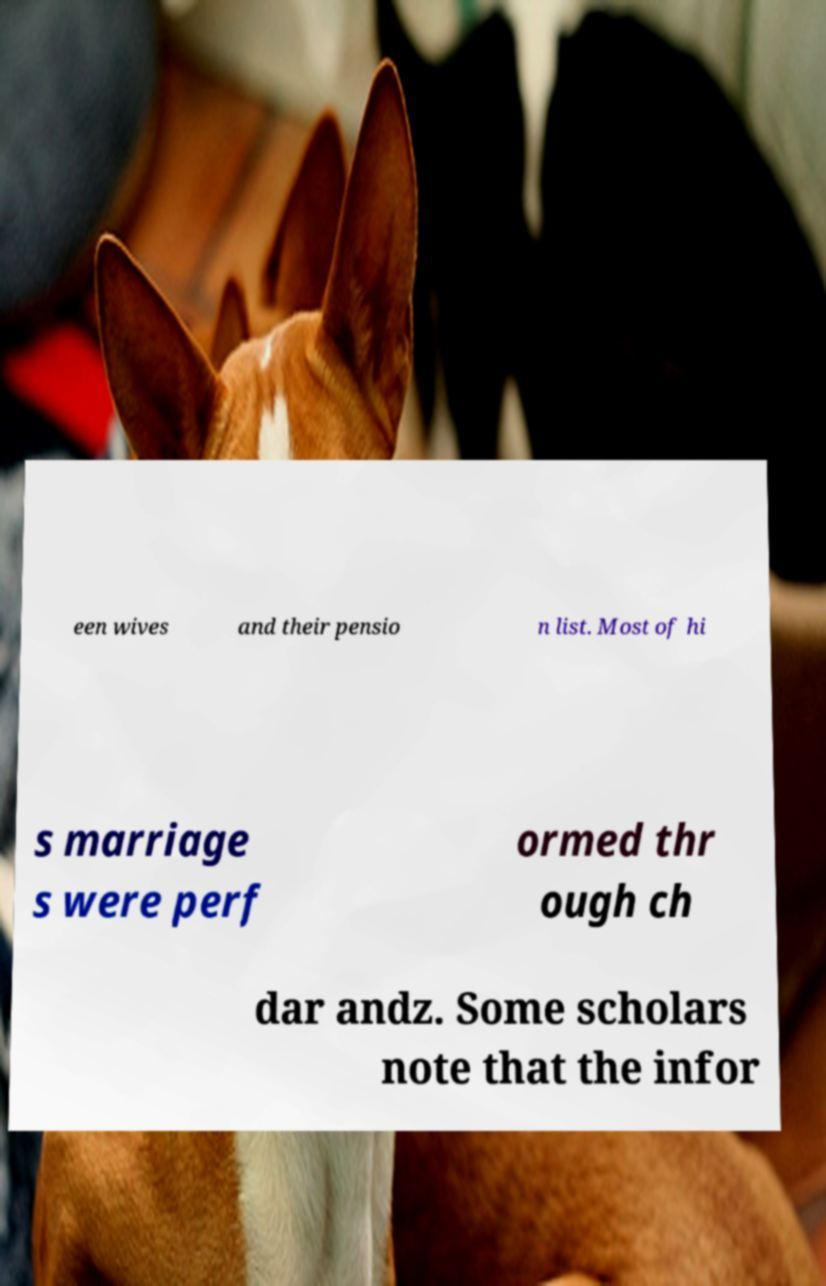There's text embedded in this image that I need extracted. Can you transcribe it verbatim? een wives and their pensio n list. Most of hi s marriage s were perf ormed thr ough ch dar andz. Some scholars note that the infor 